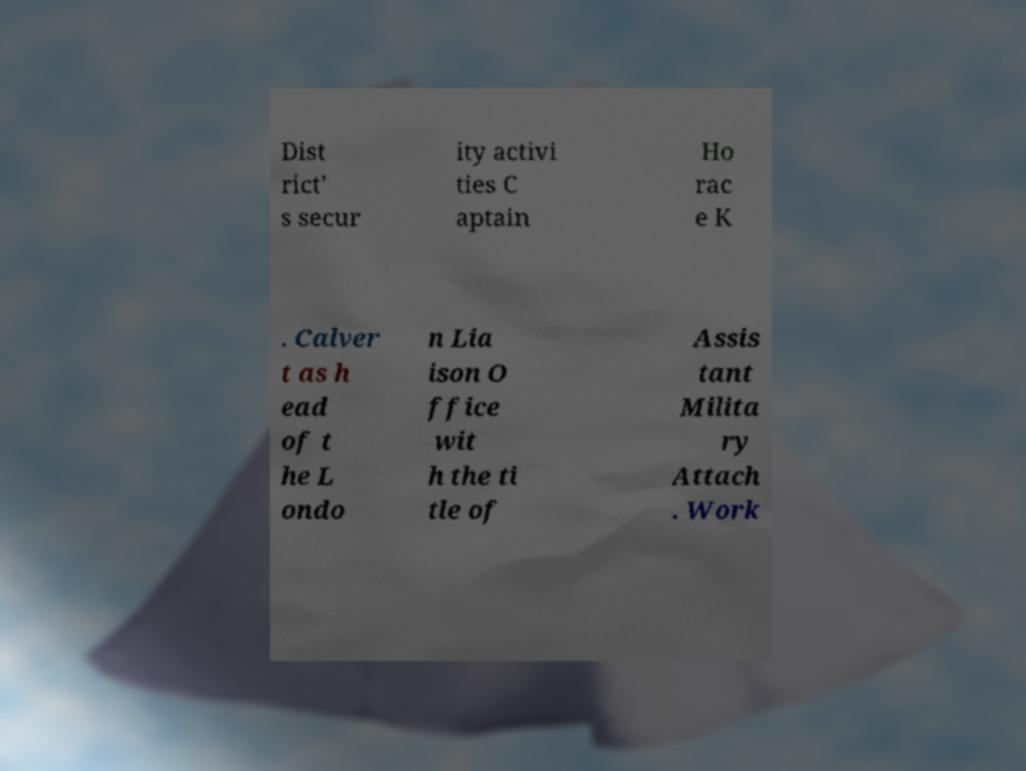For documentation purposes, I need the text within this image transcribed. Could you provide that? Dist rict' s secur ity activi ties C aptain Ho rac e K . Calver t as h ead of t he L ondo n Lia ison O ffice wit h the ti tle of Assis tant Milita ry Attach . Work 